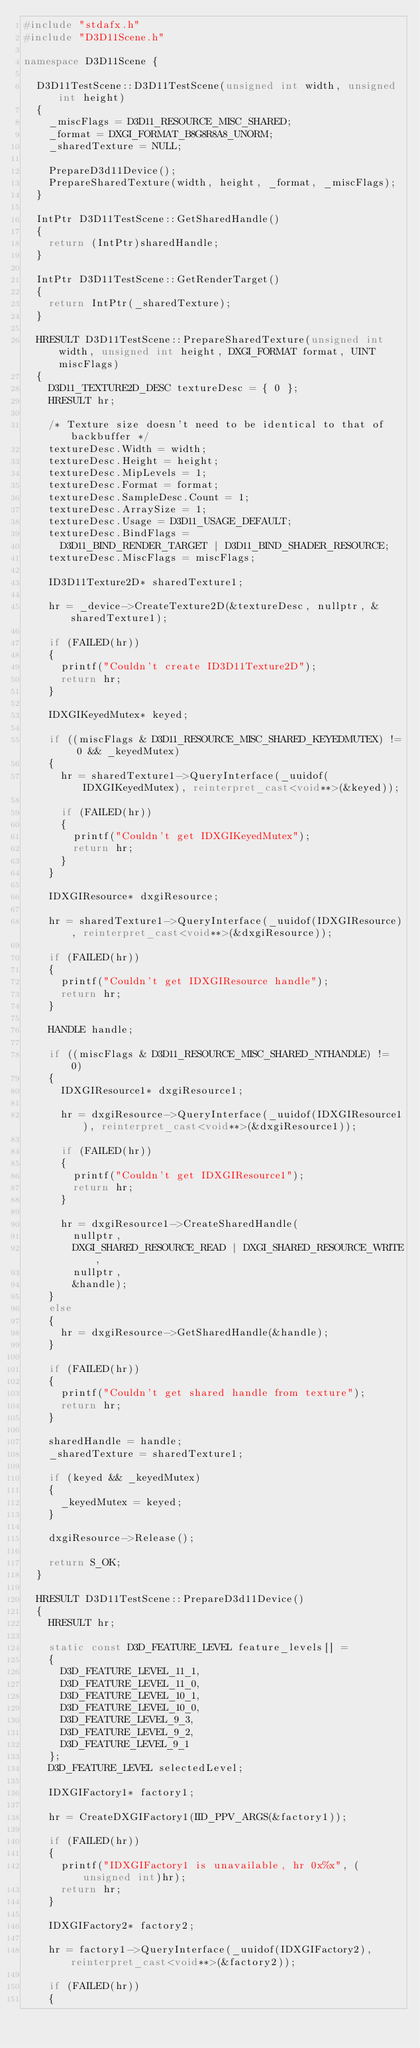Convert code to text. <code><loc_0><loc_0><loc_500><loc_500><_C++_>#include "stdafx.h"
#include "D3D11Scene.h"

namespace D3D11Scene {

	D3D11TestScene::D3D11TestScene(unsigned int width, unsigned int height)
	{
		_miscFlags = D3D11_RESOURCE_MISC_SHARED;
		_format = DXGI_FORMAT_B8G8R8A8_UNORM;
		_sharedTexture = NULL;

		PrepareD3d11Device();
		PrepareSharedTexture(width, height, _format, _miscFlags);
	}

	IntPtr D3D11TestScene::GetSharedHandle()
	{
		return (IntPtr)sharedHandle;
	}

	IntPtr D3D11TestScene::GetRenderTarget()
	{
		return IntPtr(_sharedTexture);
	}	

	HRESULT D3D11TestScene::PrepareSharedTexture(unsigned int width, unsigned int height, DXGI_FORMAT format, UINT miscFlags)
	{
		D3D11_TEXTURE2D_DESC textureDesc = { 0 };
		HRESULT hr;

		/* Texture size doesn't need to be identical to that of backbuffer */
		textureDesc.Width = width;
		textureDesc.Height = height;
		textureDesc.MipLevels = 1;
		textureDesc.Format = format;
		textureDesc.SampleDesc.Count = 1;
		textureDesc.ArraySize = 1;
		textureDesc.Usage = D3D11_USAGE_DEFAULT;
		textureDesc.BindFlags =
			D3D11_BIND_RENDER_TARGET | D3D11_BIND_SHADER_RESOURCE;
		textureDesc.MiscFlags = miscFlags;

		ID3D11Texture2D* sharedTexture1;

		hr = _device->CreateTexture2D(&textureDesc, nullptr, &sharedTexture1);

		if (FAILED(hr)) 
		{
			printf("Couldn't create ID3D11Texture2D");
			return hr;
		}

		IDXGIKeyedMutex* keyed;

		if ((miscFlags & D3D11_RESOURCE_MISC_SHARED_KEYEDMUTEX) != 0 && _keyedMutex) 
		{
			hr = sharedTexture1->QueryInterface(_uuidof(IDXGIKeyedMutex), reinterpret_cast<void**>(&keyed));

			if (FAILED(hr)) 
			{
				printf("Couldn't get IDXGIKeyedMutex");
				return hr;
			}
		}

		IDXGIResource* dxgiResource;

		hr = sharedTexture1->QueryInterface(_uuidof(IDXGIResource), reinterpret_cast<void**>(&dxgiResource));

		if (FAILED(hr)) 
		{
			printf("Couldn't get IDXGIResource handle");
			return hr;
		}

		HANDLE handle;

		if ((miscFlags & D3D11_RESOURCE_MISC_SHARED_NTHANDLE) != 0) 
		{
			IDXGIResource1* dxgiResource1;

			hr = dxgiResource->QueryInterface(_uuidof(IDXGIResource1), reinterpret_cast<void**>(&dxgiResource1));

			if (FAILED(hr)) 
			{
				printf("Couldn't get IDXGIResource1");
				return hr;
			}

			hr = dxgiResource1->CreateSharedHandle(
				nullptr,
				DXGI_SHARED_RESOURCE_READ | DXGI_SHARED_RESOURCE_WRITE, 
				nullptr,
				&handle);
		}
		else 
		{
			hr = dxgiResource->GetSharedHandle(&handle);
		}

		if (FAILED(hr)) 
		{
			printf("Couldn't get shared handle from texture");
			return hr;
		}

		sharedHandle = handle;
		_sharedTexture = sharedTexture1;

		if (keyed && _keyedMutex)
		{
			_keyedMutex = keyed;
		}		

		dxgiResource->Release();

		return S_OK;
	}

	HRESULT D3D11TestScene::PrepareD3d11Device()
	{
		HRESULT hr;

		static const D3D_FEATURE_LEVEL feature_levels[] = 
		{
		  D3D_FEATURE_LEVEL_11_1,
		  D3D_FEATURE_LEVEL_11_0,
		  D3D_FEATURE_LEVEL_10_1,
		  D3D_FEATURE_LEVEL_10_0,
		  D3D_FEATURE_LEVEL_9_3,
		  D3D_FEATURE_LEVEL_9_2,
		  D3D_FEATURE_LEVEL_9_1
		};
		D3D_FEATURE_LEVEL selectedLevel;

		IDXGIFactory1* factory1;

		hr = CreateDXGIFactory1(IID_PPV_ARGS(&factory1));

		if (FAILED(hr)) 
		{
			printf("IDXGIFactory1 is unavailable, hr 0x%x", (unsigned int)hr);
			return hr;
		}

		IDXGIFactory2* factory2;

		hr = factory1->QueryInterface(_uuidof(IDXGIFactory2), reinterpret_cast<void**>(&factory2));

		if (FAILED(hr)) 
		{</code> 